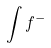Convert formula to latex. <formula><loc_0><loc_0><loc_500><loc_500>\int f ^ { - }</formula> 